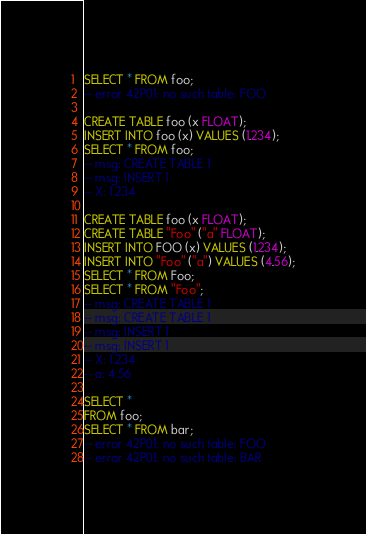<code> <loc_0><loc_0><loc_500><loc_500><_SQL_>SELECT * FROM foo;
-- error 42P01: no such table: FOO

CREATE TABLE foo (x FLOAT);
INSERT INTO foo (x) VALUES (1.234);
SELECT * FROM foo;
-- msg: CREATE TABLE 1
-- msg: INSERT 1
-- X: 1.234

CREATE TABLE foo (x FLOAT);
CREATE TABLE "Foo" ("a" FLOAT);
INSERT INTO FOO (x) VALUES (1.234);
INSERT INTO "Foo" ("a") VALUES (4.56);
SELECT * FROM Foo;
SELECT * FROM "Foo";
-- msg: CREATE TABLE 1
-- msg: CREATE TABLE 1
-- msg: INSERT 1
-- msg: INSERT 1
-- X: 1.234
-- a: 4.56

SELECT *
FROM foo;
SELECT * FROM bar;
-- error 42P01: no such table: FOO
-- error 42P01: no such table: BAR
</code> 